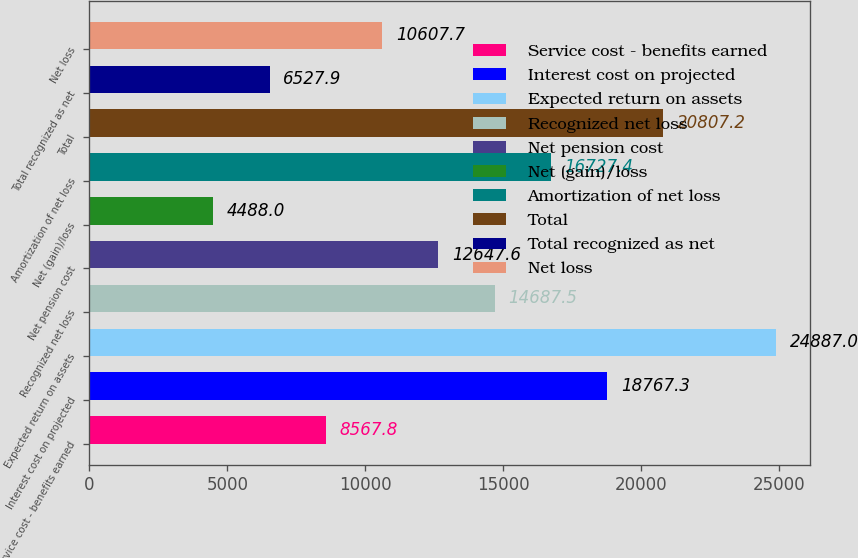Convert chart. <chart><loc_0><loc_0><loc_500><loc_500><bar_chart><fcel>Service cost - benefits earned<fcel>Interest cost on projected<fcel>Expected return on assets<fcel>Recognized net loss<fcel>Net pension cost<fcel>Net (gain)/loss<fcel>Amortization of net loss<fcel>Total<fcel>Total recognized as net<fcel>Net loss<nl><fcel>8567.8<fcel>18767.3<fcel>24887<fcel>14687.5<fcel>12647.6<fcel>4488<fcel>16727.4<fcel>20807.2<fcel>6527.9<fcel>10607.7<nl></chart> 